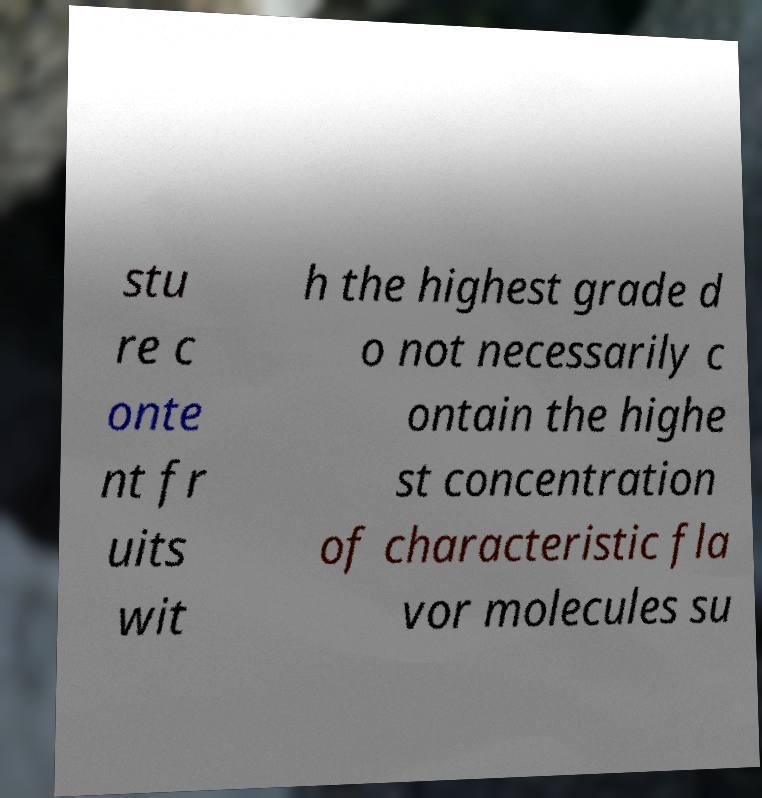I need the written content from this picture converted into text. Can you do that? stu re c onte nt fr uits wit h the highest grade d o not necessarily c ontain the highe st concentration of characteristic fla vor molecules su 